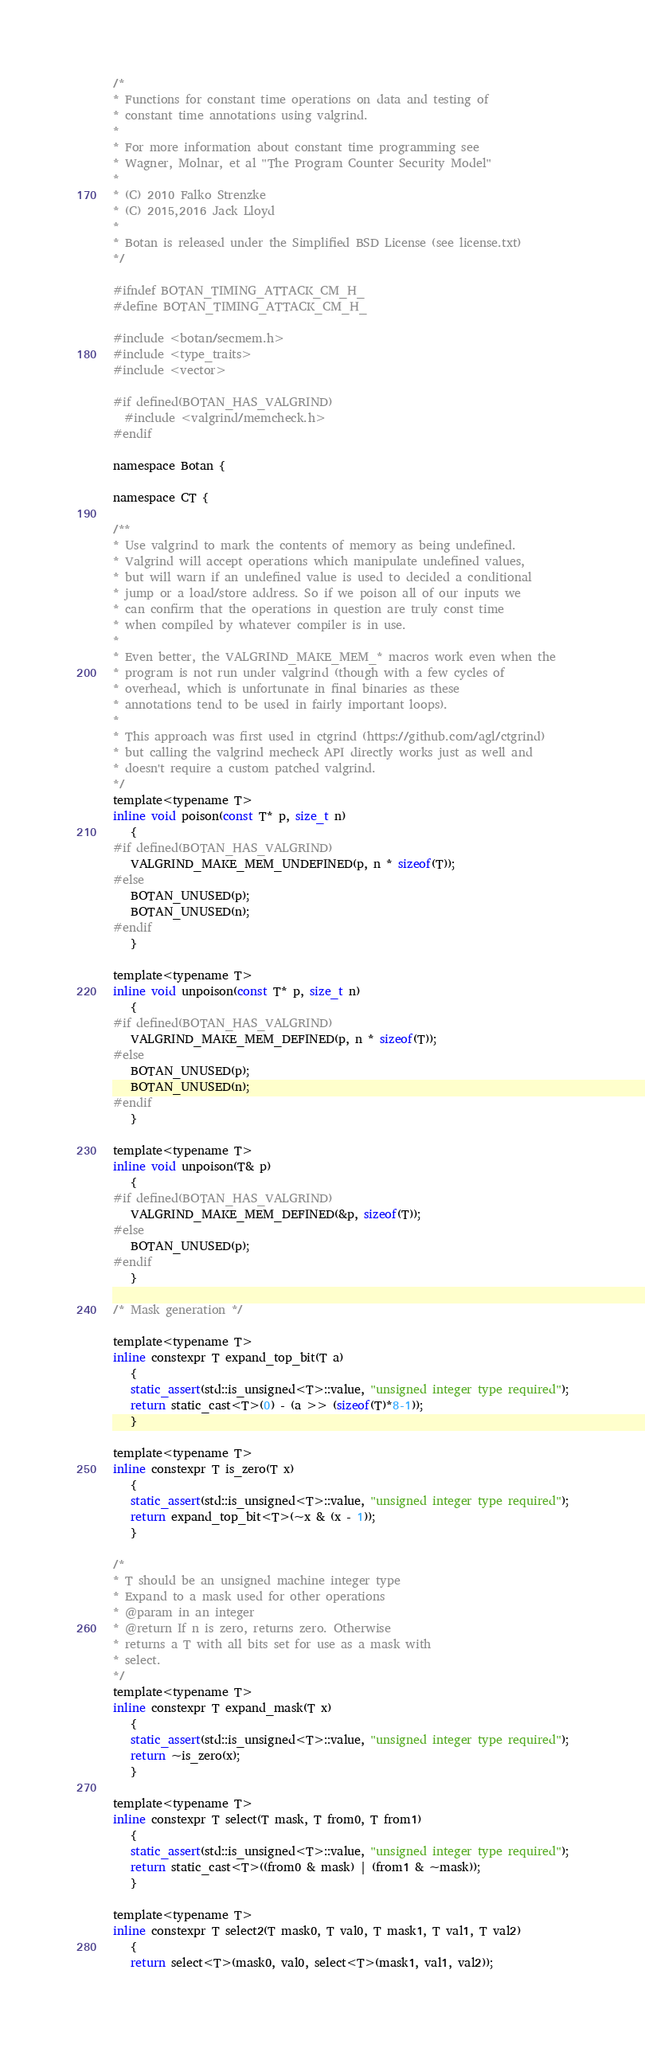<code> <loc_0><loc_0><loc_500><loc_500><_C_>/*
* Functions for constant time operations on data and testing of
* constant time annotations using valgrind.
*
* For more information about constant time programming see
* Wagner, Molnar, et al "The Program Counter Security Model"
*
* (C) 2010 Falko Strenzke
* (C) 2015,2016 Jack Lloyd
*
* Botan is released under the Simplified BSD License (see license.txt)
*/

#ifndef BOTAN_TIMING_ATTACK_CM_H_
#define BOTAN_TIMING_ATTACK_CM_H_

#include <botan/secmem.h>
#include <type_traits>
#include <vector>

#if defined(BOTAN_HAS_VALGRIND)
  #include <valgrind/memcheck.h>
#endif

namespace Botan {

namespace CT {

/**
* Use valgrind to mark the contents of memory as being undefined.
* Valgrind will accept operations which manipulate undefined values,
* but will warn if an undefined value is used to decided a conditional
* jump or a load/store address. So if we poison all of our inputs we
* can confirm that the operations in question are truly const time
* when compiled by whatever compiler is in use.
*
* Even better, the VALGRIND_MAKE_MEM_* macros work even when the
* program is not run under valgrind (though with a few cycles of
* overhead, which is unfortunate in final binaries as these
* annotations tend to be used in fairly important loops).
*
* This approach was first used in ctgrind (https://github.com/agl/ctgrind)
* but calling the valgrind mecheck API directly works just as well and
* doesn't require a custom patched valgrind.
*/
template<typename T>
inline void poison(const T* p, size_t n)
   {
#if defined(BOTAN_HAS_VALGRIND)
   VALGRIND_MAKE_MEM_UNDEFINED(p, n * sizeof(T));
#else
   BOTAN_UNUSED(p);
   BOTAN_UNUSED(n);
#endif
   }

template<typename T>
inline void unpoison(const T* p, size_t n)
   {
#if defined(BOTAN_HAS_VALGRIND)
   VALGRIND_MAKE_MEM_DEFINED(p, n * sizeof(T));
#else
   BOTAN_UNUSED(p);
   BOTAN_UNUSED(n);
#endif
   }

template<typename T>
inline void unpoison(T& p)
   {
#if defined(BOTAN_HAS_VALGRIND)
   VALGRIND_MAKE_MEM_DEFINED(&p, sizeof(T));
#else
   BOTAN_UNUSED(p);
#endif
   }

/* Mask generation */

template<typename T>
inline constexpr T expand_top_bit(T a)
   {
   static_assert(std::is_unsigned<T>::value, "unsigned integer type required");
   return static_cast<T>(0) - (a >> (sizeof(T)*8-1));
   }

template<typename T>
inline constexpr T is_zero(T x)
   {
   static_assert(std::is_unsigned<T>::value, "unsigned integer type required");
   return expand_top_bit<T>(~x & (x - 1));
   }

/*
* T should be an unsigned machine integer type
* Expand to a mask used for other operations
* @param in an integer
* @return If n is zero, returns zero. Otherwise
* returns a T with all bits set for use as a mask with
* select.
*/
template<typename T>
inline constexpr T expand_mask(T x)
   {
   static_assert(std::is_unsigned<T>::value, "unsigned integer type required");
   return ~is_zero(x);
   }

template<typename T>
inline constexpr T select(T mask, T from0, T from1)
   {
   static_assert(std::is_unsigned<T>::value, "unsigned integer type required");
   return static_cast<T>((from0 & mask) | (from1 & ~mask));
   }

template<typename T>
inline constexpr T select2(T mask0, T val0, T mask1, T val1, T val2)
   {
   return select<T>(mask0, val0, select<T>(mask1, val1, val2));</code> 